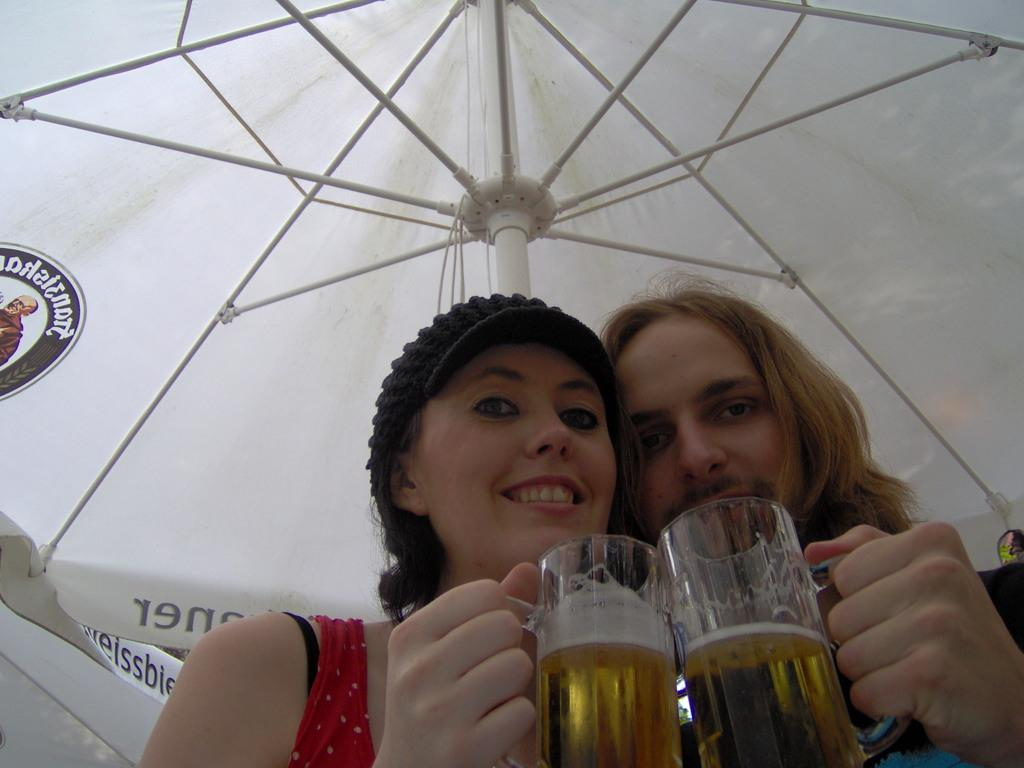How many people are in the image? There are two persons in the image. What are the persons holding in the image? The persons are holding a glass. Can you describe the visibility of the persons in the image? The persons are partially visible. What type of shelter is present in the image? The persons are under an umbrella tent. Where is the image taken? The image is taken inside a hut. What type of seat is the son sitting on in the image? There is no son present in the image, and therefore no seat for a son to sit on. 